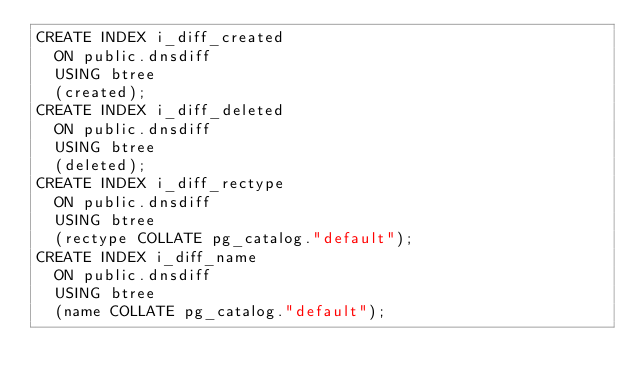Convert code to text. <code><loc_0><loc_0><loc_500><loc_500><_SQL_>CREATE INDEX i_diff_created
  ON public.dnsdiff
  USING btree
  (created);
CREATE INDEX i_diff_deleted
  ON public.dnsdiff
  USING btree
  (deleted);
CREATE INDEX i_diff_rectype
  ON public.dnsdiff
  USING btree
  (rectype COLLATE pg_catalog."default");
CREATE INDEX i_diff_name
  ON public.dnsdiff
  USING btree
  (name COLLATE pg_catalog."default");
</code> 